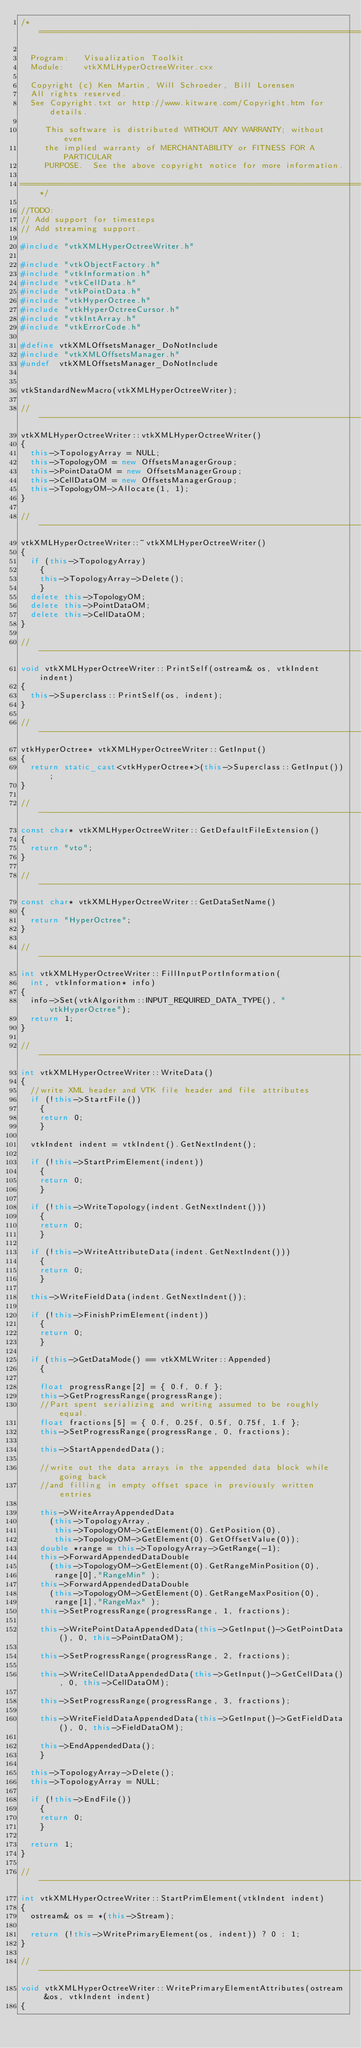<code> <loc_0><loc_0><loc_500><loc_500><_C++_>/*=========================================================================

  Program:   Visualization Toolkit
  Module:    vtkXMLHyperOctreeWriter.cxx

  Copyright (c) Ken Martin, Will Schroeder, Bill Lorensen
  All rights reserved.
  See Copyright.txt or http://www.kitware.com/Copyright.htm for details.

     This software is distributed WITHOUT ANY WARRANTY; without even
     the implied warranty of MERCHANTABILITY or FITNESS FOR A PARTICULAR
     PURPOSE.  See the above copyright notice for more information.

=========================================================================*/

//TODO:
// Add support for timesteps
// Add streaming support.

#include "vtkXMLHyperOctreeWriter.h"

#include "vtkObjectFactory.h"
#include "vtkInformation.h"
#include "vtkCellData.h"
#include "vtkPointData.h"
#include "vtkHyperOctree.h"
#include "vtkHyperOctreeCursor.h"
#include "vtkIntArray.h"
#include "vtkErrorCode.h"

#define vtkXMLOffsetsManager_DoNotInclude
#include "vtkXMLOffsetsManager.h"
#undef  vtkXMLOffsetsManager_DoNotInclude


vtkStandardNewMacro(vtkXMLHyperOctreeWriter);

//----------------------------------------------------------------------------
vtkXMLHyperOctreeWriter::vtkXMLHyperOctreeWriter()
{
  this->TopologyArray = NULL;
  this->TopologyOM = new OffsetsManagerGroup;
  this->PointDataOM = new OffsetsManagerGroup;
  this->CellDataOM = new OffsetsManagerGroup;
  this->TopologyOM->Allocate(1, 1);
}

//----------------------------------------------------------------------------
vtkXMLHyperOctreeWriter::~vtkXMLHyperOctreeWriter()
{
  if (this->TopologyArray)
    {
    this->TopologyArray->Delete();
    }
  delete this->TopologyOM;
  delete this->PointDataOM;
  delete this->CellDataOM;
}

//----------------------------------------------------------------------------
void vtkXMLHyperOctreeWriter::PrintSelf(ostream& os, vtkIndent indent)
{
  this->Superclass::PrintSelf(os, indent);
}

//----------------------------------------------------------------------------
vtkHyperOctree* vtkXMLHyperOctreeWriter::GetInput()
{
  return static_cast<vtkHyperOctree*>(this->Superclass::GetInput());
}

//----------------------------------------------------------------------------
const char* vtkXMLHyperOctreeWriter::GetDefaultFileExtension()
{
  return "vto";
}

//----------------------------------------------------------------------------
const char* vtkXMLHyperOctreeWriter::GetDataSetName()
{
  return "HyperOctree";
}

//----------------------------------------------------------------------------
int vtkXMLHyperOctreeWriter::FillInputPortInformation(
  int, vtkInformation* info)
{
  info->Set(vtkAlgorithm::INPUT_REQUIRED_DATA_TYPE(), "vtkHyperOctree");
  return 1;
}

//----------------------------------------------------------------------------
int vtkXMLHyperOctreeWriter::WriteData()
{
  //write XML header and VTK file header and file attributes
  if (!this->StartFile())
    {
    return 0;
    }

  vtkIndent indent = vtkIndent().GetNextIndent();

  if (!this->StartPrimElement(indent))
    {
    return 0;
    }

  if (!this->WriteTopology(indent.GetNextIndent()))
    {
    return 0;
    }

  if (!this->WriteAttributeData(indent.GetNextIndent()))
    {
    return 0;
    }

  this->WriteFieldData(indent.GetNextIndent());

  if (!this->FinishPrimElement(indent))
    {
    return 0;
    }

  if (this->GetDataMode() == vtkXMLWriter::Appended)
    {

    float progressRange[2] = { 0.f, 0.f };
    this->GetProgressRange(progressRange);
    //Part spent serializing and writing assumed to be roughly equal.
    float fractions[5] = { 0.f, 0.25f, 0.5f, 0.75f, 1.f };
    this->SetProgressRange(progressRange, 0, fractions);

    this->StartAppendedData();

    //write out the data arrays in the appended data block while going back
    //and filling in empty offset space in previously written entries

    this->WriteArrayAppendedData
      (this->TopologyArray,
       this->TopologyOM->GetElement(0).GetPosition(0),
       this->TopologyOM->GetElement(0).GetOffsetValue(0));
    double *range = this->TopologyArray->GetRange(-1);
    this->ForwardAppendedDataDouble
      (this->TopologyOM->GetElement(0).GetRangeMinPosition(0),
       range[0],"RangeMin" );
    this->ForwardAppendedDataDouble
      (this->TopologyOM->GetElement(0).GetRangeMaxPosition(0),
       range[1],"RangeMax" );
    this->SetProgressRange(progressRange, 1, fractions);

    this->WritePointDataAppendedData(this->GetInput()->GetPointData(), 0, this->PointDataOM);

    this->SetProgressRange(progressRange, 2, fractions);

    this->WriteCellDataAppendedData(this->GetInput()->GetCellData(), 0, this->CellDataOM);

    this->SetProgressRange(progressRange, 3, fractions);

    this->WriteFieldDataAppendedData(this->GetInput()->GetFieldData(), 0, this->FieldDataOM);

    this->EndAppendedData();
    }

  this->TopologyArray->Delete();
  this->TopologyArray = NULL;

  if (!this->EndFile())
    {
    return 0;
    }

  return 1;
}

//----------------------------------------------------------------------------
int vtkXMLHyperOctreeWriter::StartPrimElement(vtkIndent indent)
{
  ostream& os = *(this->Stream);

  return (!this->WritePrimaryElement(os, indent)) ? 0 : 1;
}

//----------------------------------------------------------------------------
void vtkXMLHyperOctreeWriter::WritePrimaryElementAttributes(ostream &os, vtkIndent indent)
{</code> 